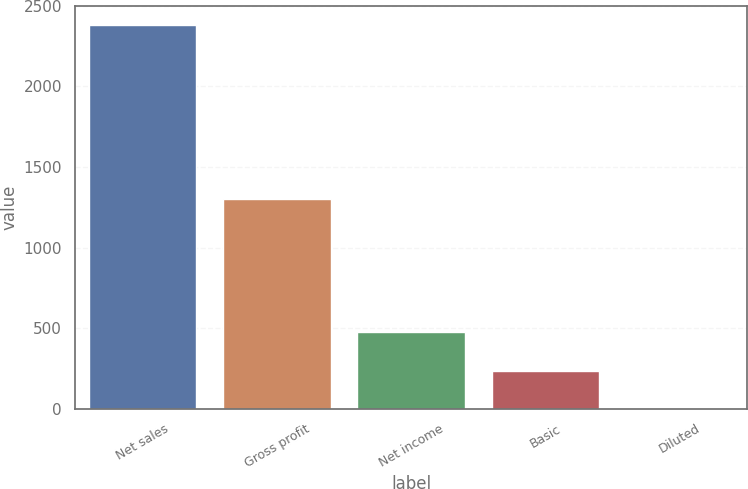Convert chart. <chart><loc_0><loc_0><loc_500><loc_500><bar_chart><fcel>Net sales<fcel>Gross profit<fcel>Net income<fcel>Basic<fcel>Diluted<nl><fcel>2381.7<fcel>1302.6<fcel>476.79<fcel>238.68<fcel>0.57<nl></chart> 